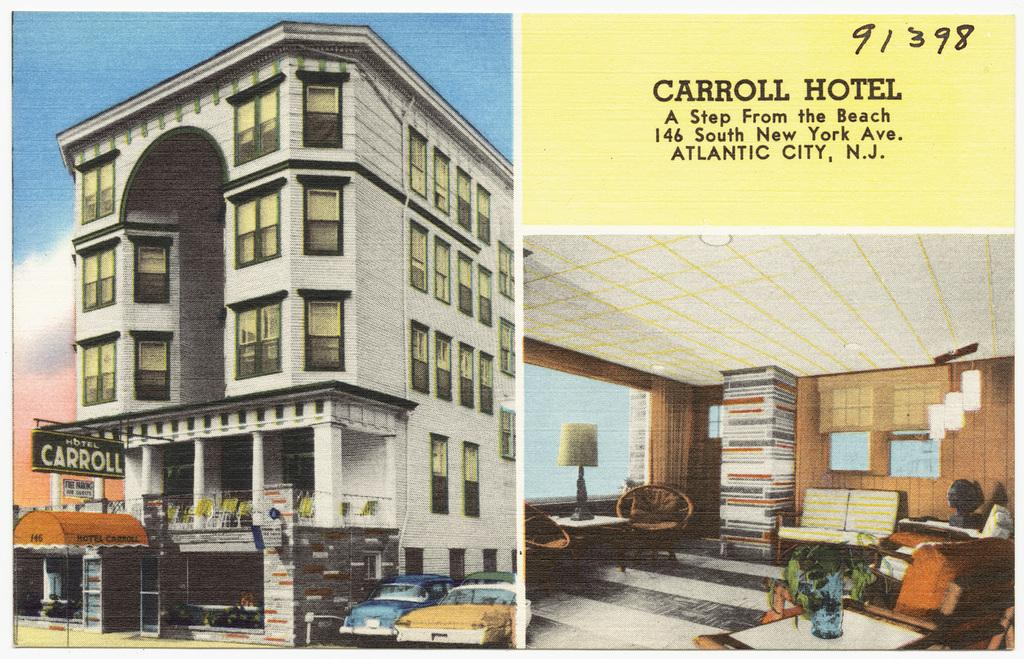Provide a one-sentence caption for the provided image. The outside of the Caroll Hotel is shown on this postcard, that shows the address for the hotel that is a "step from the beach" in Atlantic City NJ. 